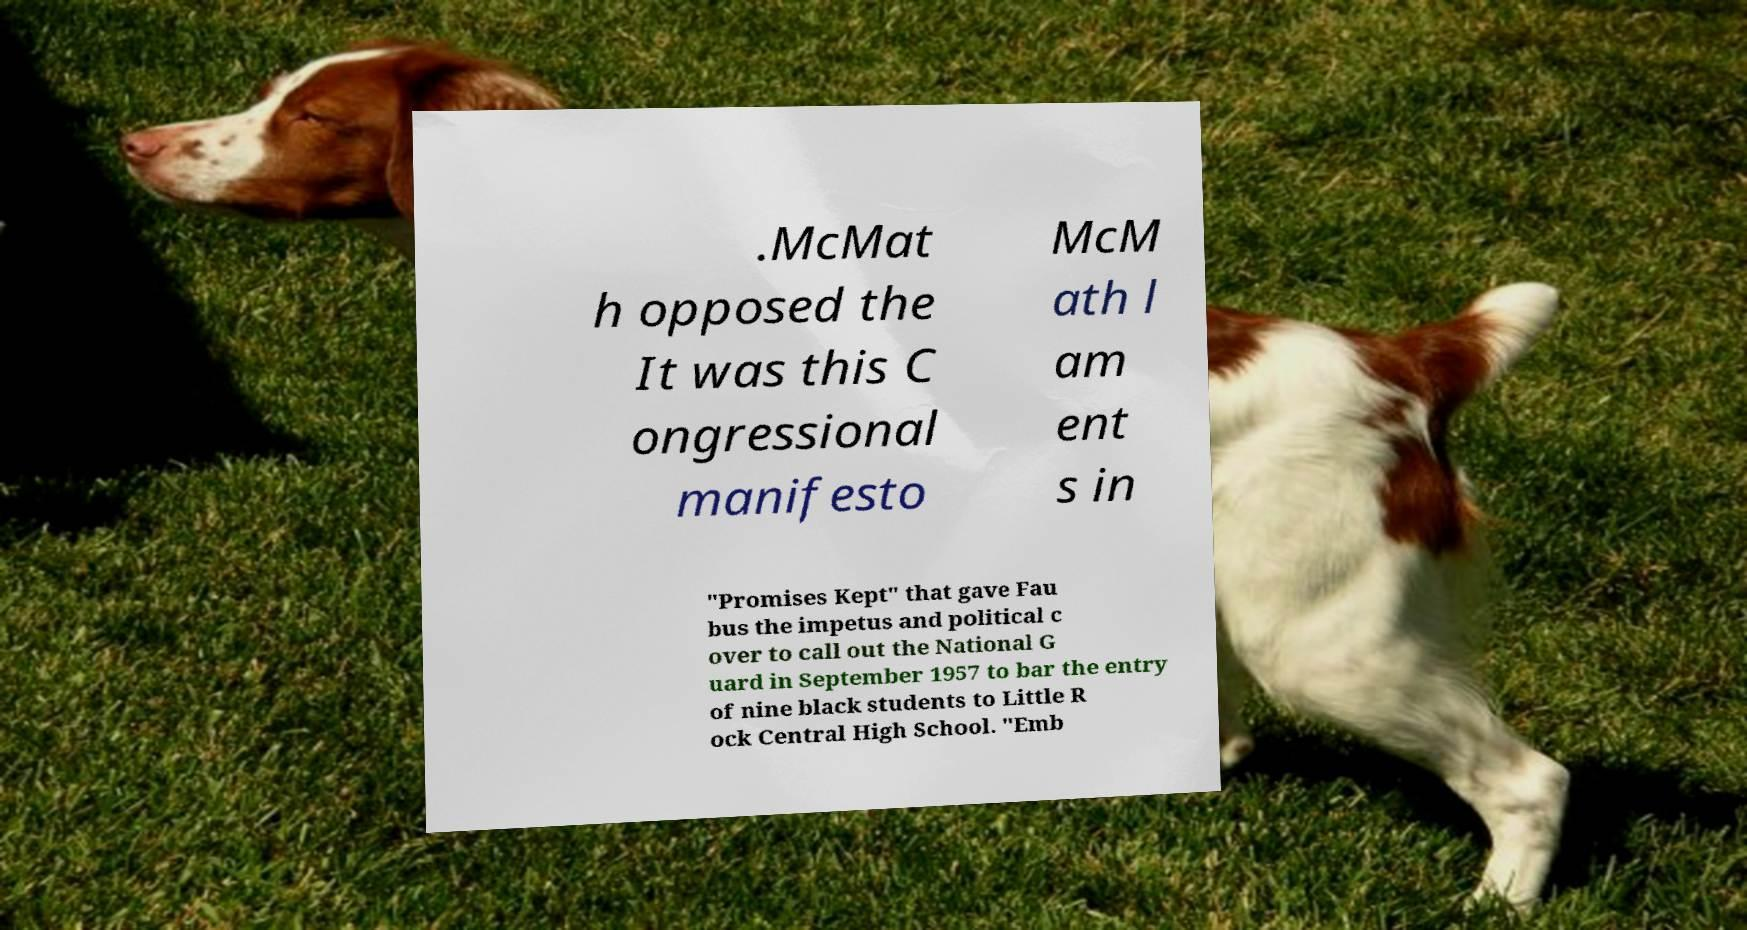There's text embedded in this image that I need extracted. Can you transcribe it verbatim? .McMat h opposed the It was this C ongressional manifesto McM ath l am ent s in "Promises Kept" that gave Fau bus the impetus and political c over to call out the National G uard in September 1957 to bar the entry of nine black students to Little R ock Central High School. "Emb 